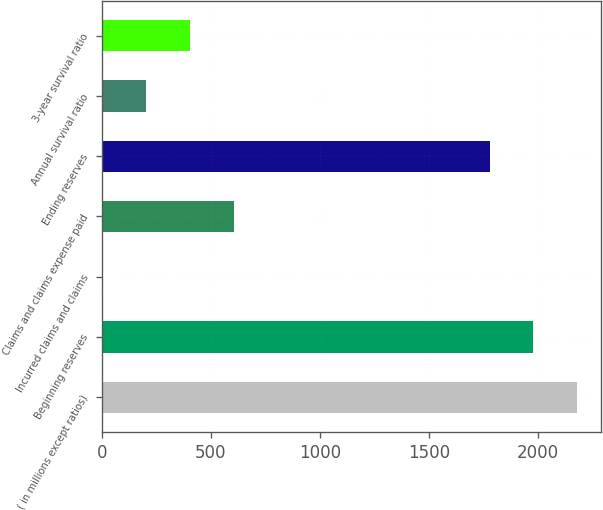Convert chart to OTSL. <chart><loc_0><loc_0><loc_500><loc_500><bar_chart><fcel>( in millions except ratios)<fcel>Beginning reserves<fcel>Incurred claims and claims<fcel>Claims and claims expense paid<fcel>Ending reserves<fcel>Annual survival ratio<fcel>3-year survival ratio<nl><fcel>2181.2<fcel>1980.6<fcel>3<fcel>604.8<fcel>1780<fcel>203.6<fcel>404.2<nl></chart> 